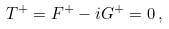Convert formula to latex. <formula><loc_0><loc_0><loc_500><loc_500>T ^ { + } = F ^ { + } - i G ^ { + } = 0 \, ,</formula> 